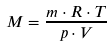<formula> <loc_0><loc_0><loc_500><loc_500>M = \frac { m \cdot R \cdot T } { p \cdot V }</formula> 